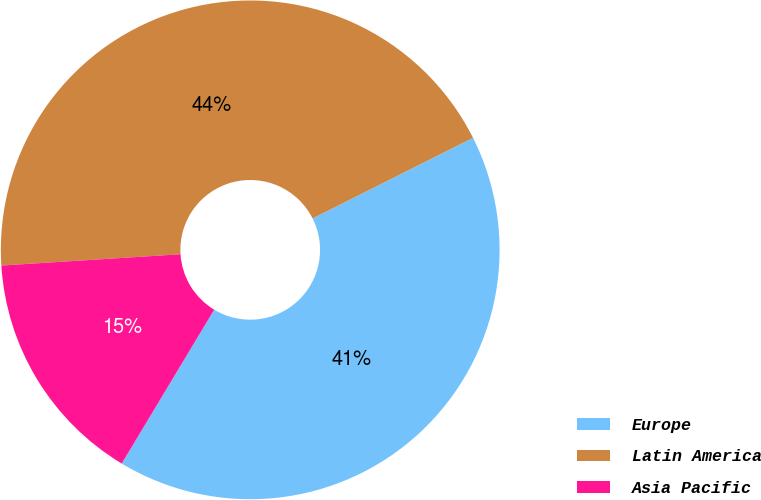<chart> <loc_0><loc_0><loc_500><loc_500><pie_chart><fcel>Europe<fcel>Latin America<fcel>Asia Pacific<nl><fcel>41.03%<fcel>43.59%<fcel>15.38%<nl></chart> 